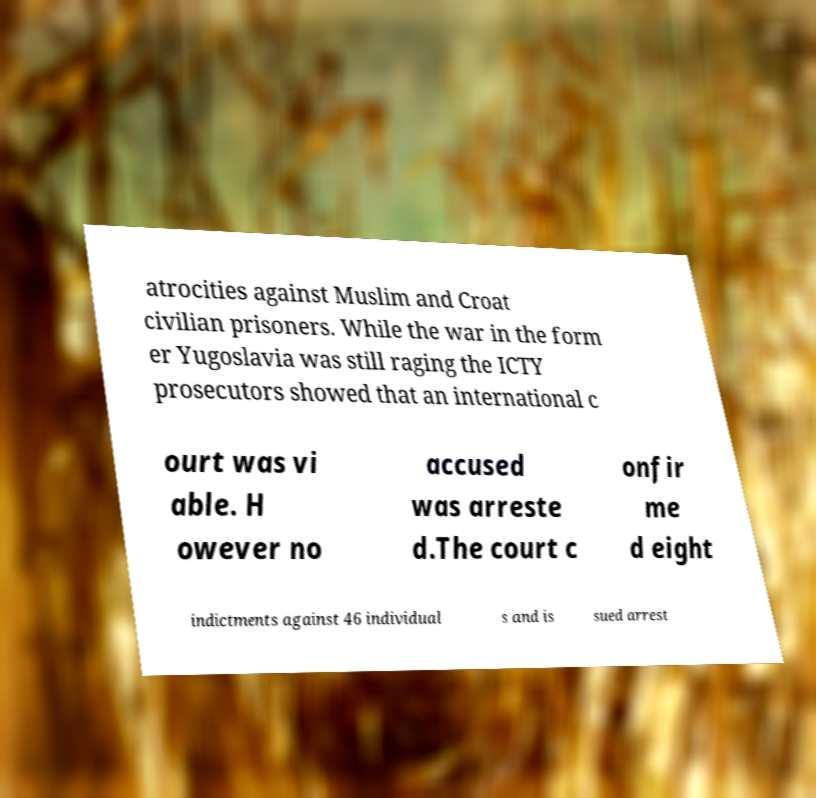Can you read and provide the text displayed in the image?This photo seems to have some interesting text. Can you extract and type it out for me? atrocities against Muslim and Croat civilian prisoners. While the war in the form er Yugoslavia was still raging the ICTY prosecutors showed that an international c ourt was vi able. H owever no accused was arreste d.The court c onfir me d eight indictments against 46 individual s and is sued arrest 